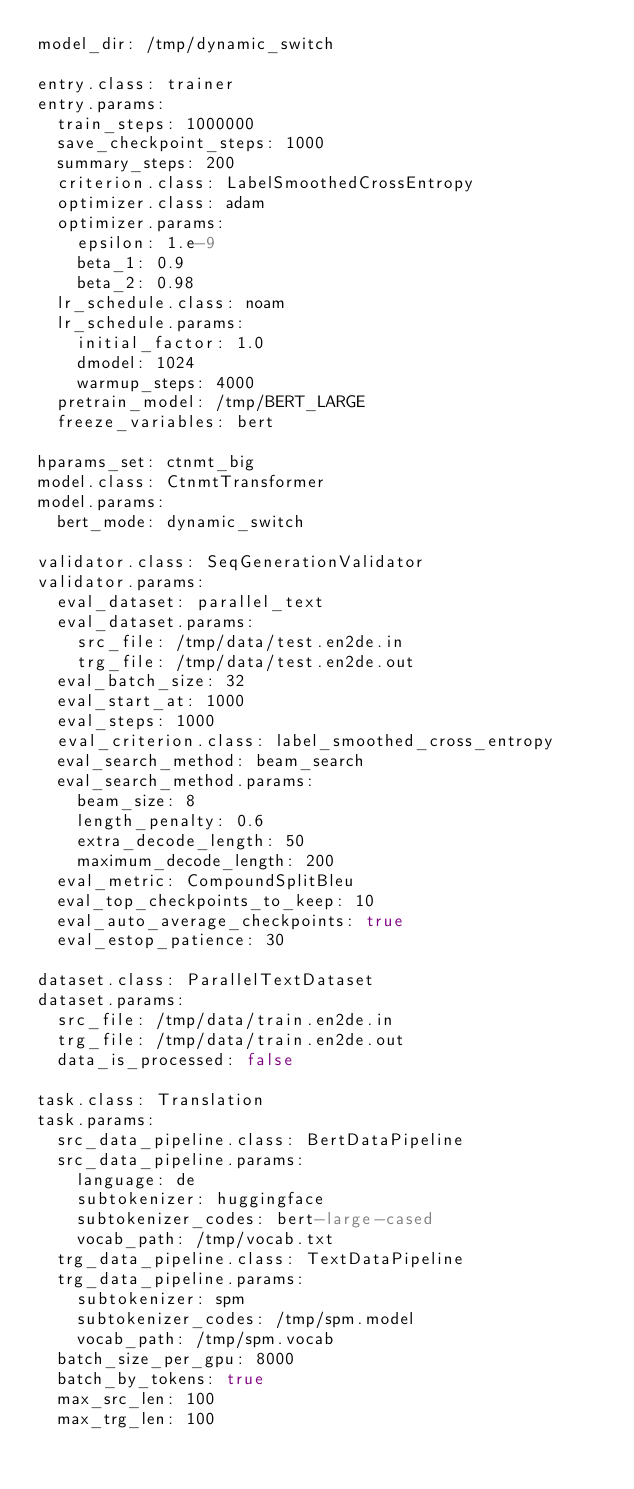Convert code to text. <code><loc_0><loc_0><loc_500><loc_500><_YAML_>model_dir: /tmp/dynamic_switch

entry.class: trainer
entry.params:
  train_steps: 1000000
  save_checkpoint_steps: 1000
  summary_steps: 200
  criterion.class: LabelSmoothedCrossEntropy
  optimizer.class: adam
  optimizer.params:
    epsilon: 1.e-9
    beta_1: 0.9
    beta_2: 0.98
  lr_schedule.class: noam
  lr_schedule.params:
    initial_factor: 1.0
    dmodel: 1024
    warmup_steps: 4000
  pretrain_model: /tmp/BERT_LARGE
  freeze_variables: bert

hparams_set: ctnmt_big
model.class: CtnmtTransformer
model.params:
  bert_mode: dynamic_switch

validator.class: SeqGenerationValidator
validator.params:
  eval_dataset: parallel_text
  eval_dataset.params:
    src_file: /tmp/data/test.en2de.in
    trg_file: /tmp/data/test.en2de.out
  eval_batch_size: 32
  eval_start_at: 1000
  eval_steps: 1000
  eval_criterion.class: label_smoothed_cross_entropy
  eval_search_method: beam_search
  eval_search_method.params:
    beam_size: 8
    length_penalty: 0.6
    extra_decode_length: 50
    maximum_decode_length: 200
  eval_metric: CompoundSplitBleu
  eval_top_checkpoints_to_keep: 10
  eval_auto_average_checkpoints: true
  eval_estop_patience: 30

dataset.class: ParallelTextDataset
dataset.params:
  src_file: /tmp/data/train.en2de.in
  trg_file: /tmp/data/train.en2de.out
  data_is_processed: false

task.class: Translation
task.params:
  src_data_pipeline.class: BertDataPipeline
  src_data_pipeline.params:
    language: de
    subtokenizer: huggingface
    subtokenizer_codes: bert-large-cased
    vocab_path: /tmp/vocab.txt
  trg_data_pipeline.class: TextDataPipeline
  trg_data_pipeline.params:
    subtokenizer: spm
    subtokenizer_codes: /tmp/spm.model
    vocab_path: /tmp/spm.vocab
  batch_size_per_gpu: 8000
  batch_by_tokens: true
  max_src_len: 100
  max_trg_len: 100
</code> 